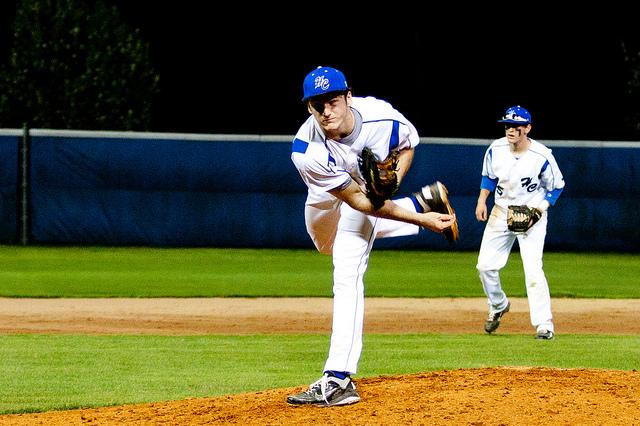Why does the man stand on one leg? Please explain your reasoning. pitching ball. The man is pitching. 